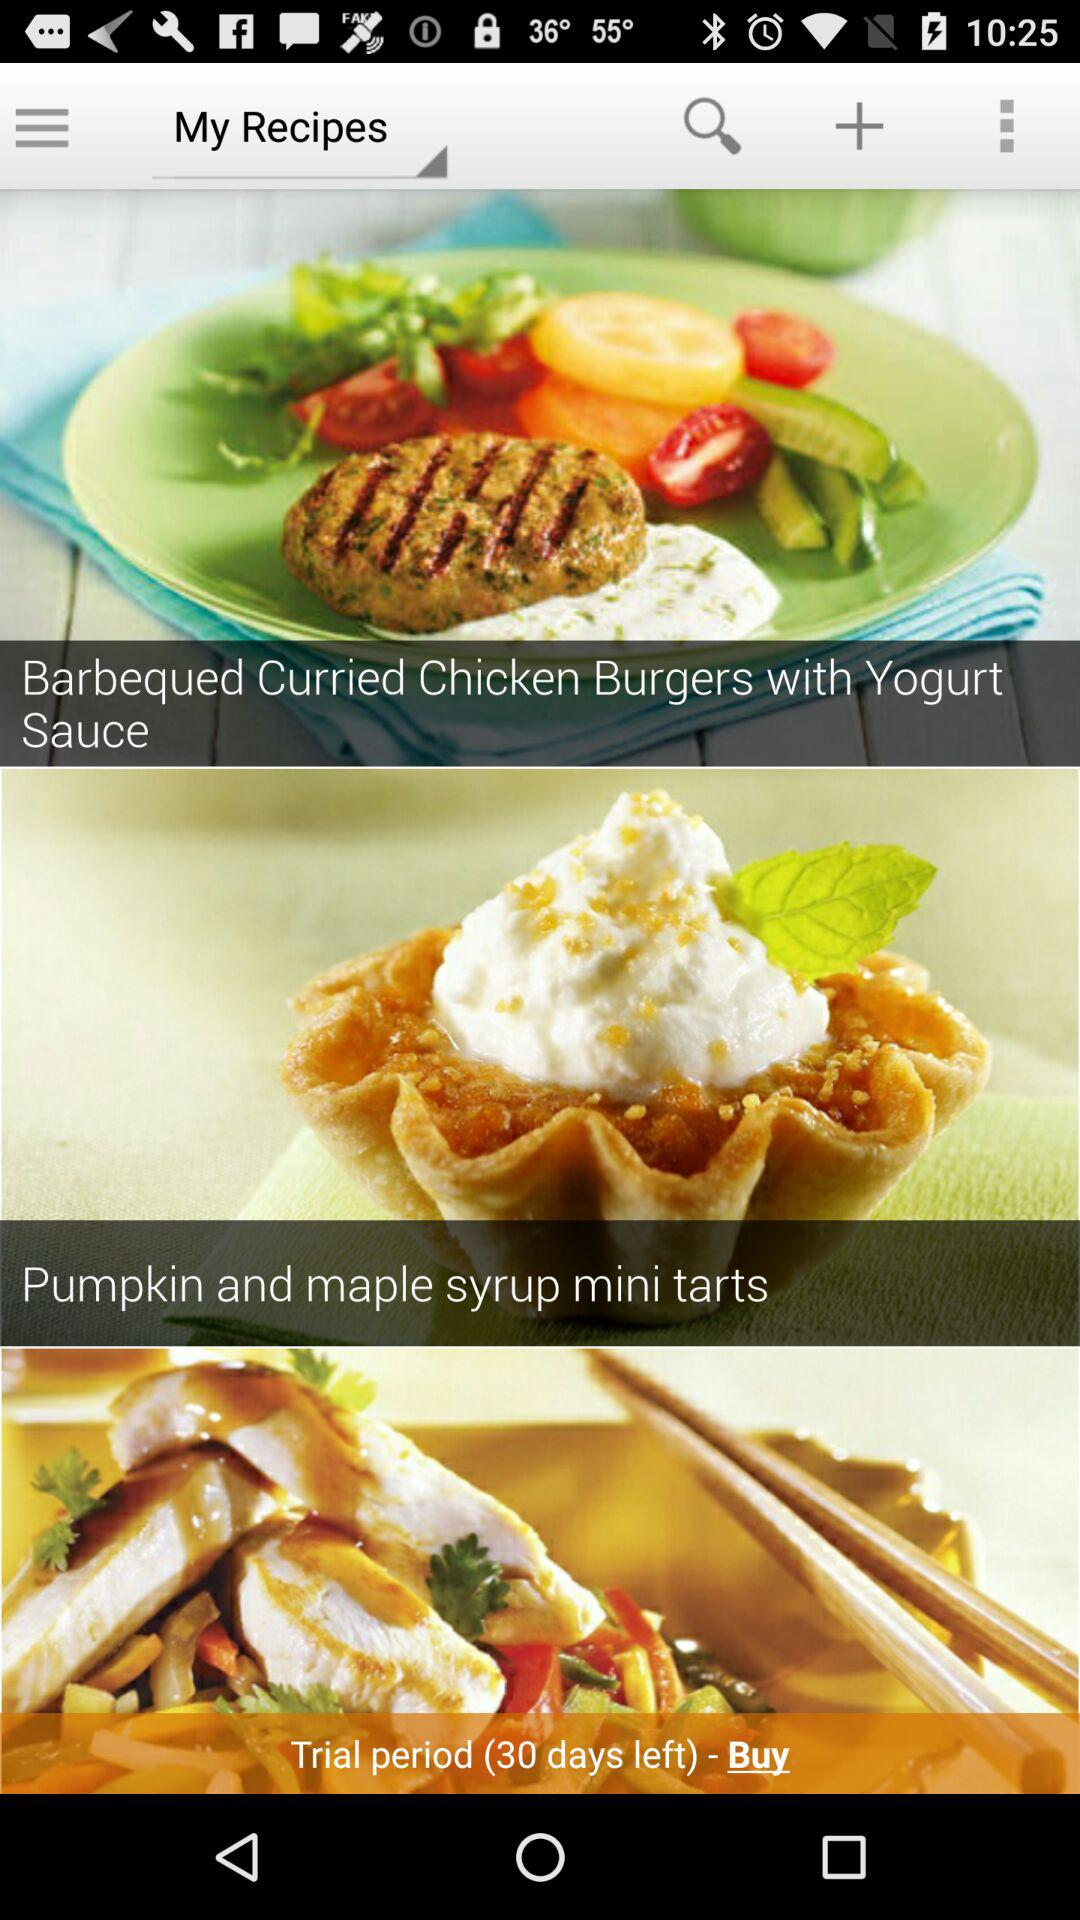How many calories are in "Pumpkin and maple syrup mini tarts"?
When the provided information is insufficient, respond with <no answer>. <no answer> 